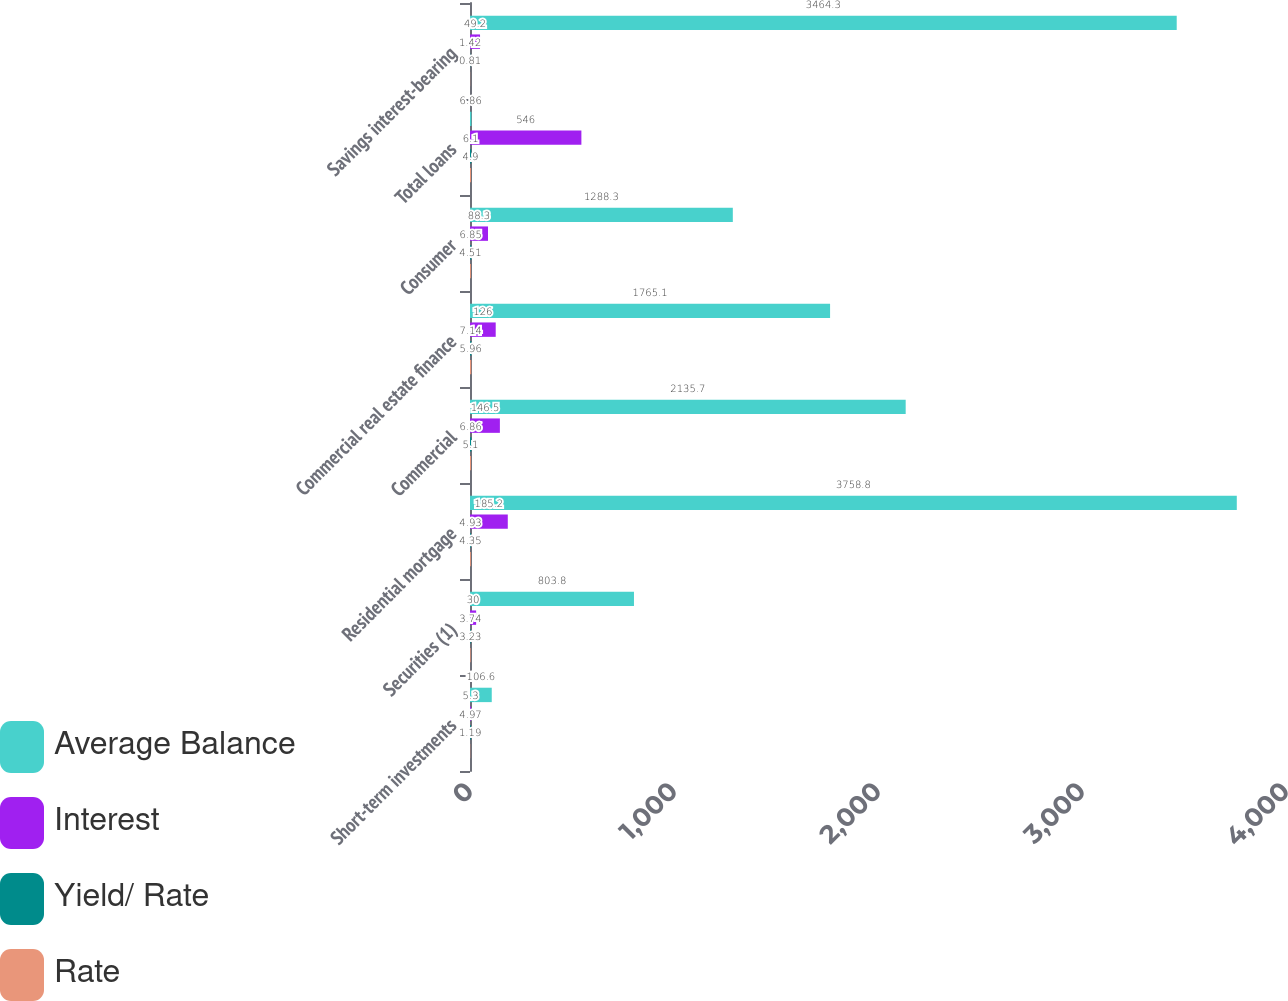Convert chart to OTSL. <chart><loc_0><loc_0><loc_500><loc_500><stacked_bar_chart><ecel><fcel>Short-term investments<fcel>Securities (1)<fcel>Residential mortgage<fcel>Commercial<fcel>Commercial real estate finance<fcel>Consumer<fcel>Total loans<fcel>Savings interest-bearing<nl><fcel>Average Balance<fcel>106.6<fcel>803.8<fcel>3758.8<fcel>2135.7<fcel>1765.1<fcel>1288.3<fcel>6.86<fcel>3464.3<nl><fcel>Interest<fcel>5.3<fcel>30<fcel>185.2<fcel>146.5<fcel>126<fcel>88.3<fcel>546<fcel>49.2<nl><fcel>Yield/ Rate<fcel>4.97<fcel>3.74<fcel>4.93<fcel>6.86<fcel>7.14<fcel>6.85<fcel>6.1<fcel>1.42<nl><fcel>Rate<fcel>1.19<fcel>3.23<fcel>4.35<fcel>5.1<fcel>5.96<fcel>4.51<fcel>4.9<fcel>0.81<nl></chart> 